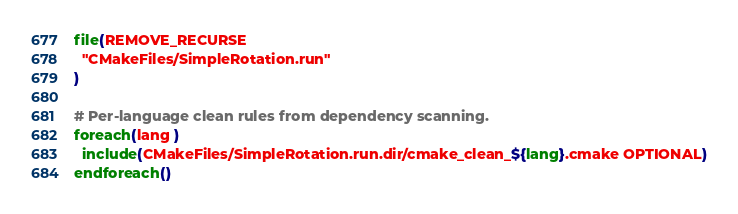<code> <loc_0><loc_0><loc_500><loc_500><_CMake_>file(REMOVE_RECURSE
  "CMakeFiles/SimpleRotation.run"
)

# Per-language clean rules from dependency scanning.
foreach(lang )
  include(CMakeFiles/SimpleRotation.run.dir/cmake_clean_${lang}.cmake OPTIONAL)
endforeach()
</code> 